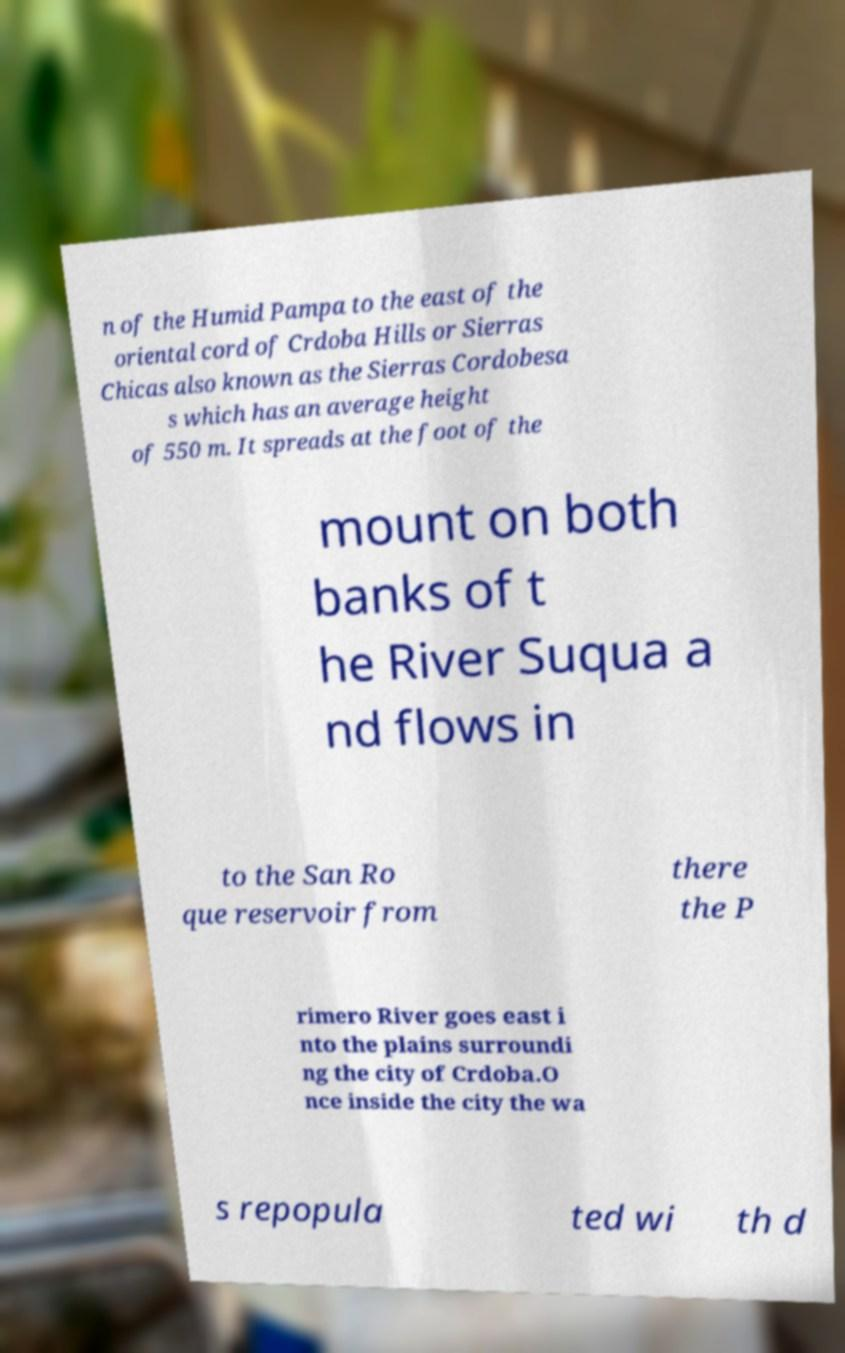Could you assist in decoding the text presented in this image and type it out clearly? n of the Humid Pampa to the east of the oriental cord of Crdoba Hills or Sierras Chicas also known as the Sierras Cordobesa s which has an average height of 550 m. It spreads at the foot of the mount on both banks of t he River Suqua a nd flows in to the San Ro que reservoir from there the P rimero River goes east i nto the plains surroundi ng the city of Crdoba.O nce inside the city the wa s repopula ted wi th d 